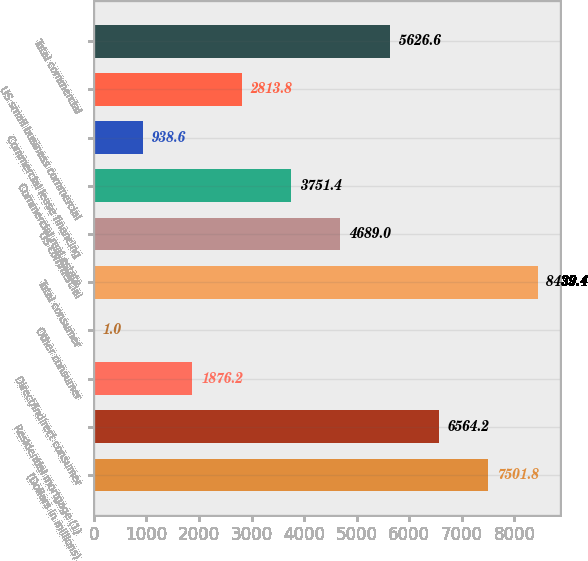Convert chart to OTSL. <chart><loc_0><loc_0><loc_500><loc_500><bar_chart><fcel>(Dollars in millions)<fcel>Residential mortgage (1)<fcel>Direct/Indirect consumer<fcel>Other consumer<fcel>Total consumer<fcel>US commercial<fcel>Commercial real estate<fcel>Commercial lease financing<fcel>US small business commercial<fcel>Total commercial<nl><fcel>7501.8<fcel>6564.2<fcel>1876.2<fcel>1<fcel>8439.4<fcel>4689<fcel>3751.4<fcel>938.6<fcel>2813.8<fcel>5626.6<nl></chart> 